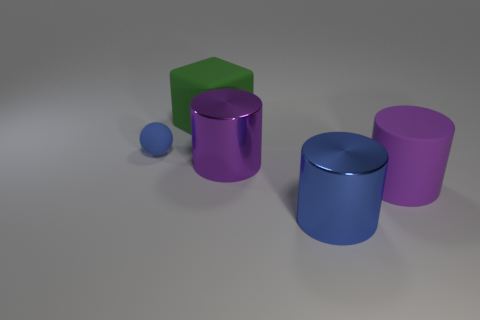There is a blue metallic thing; does it have the same shape as the large purple matte object in front of the small sphere?
Offer a terse response. Yes. There is a matte thing that is right of the tiny matte thing and behind the big rubber cylinder; what is its size?
Make the answer very short. Large. Is there a large blue object that has the same material as the tiny ball?
Provide a succinct answer. No. There is a shiny thing that is the same color as the tiny ball; what is its size?
Ensure brevity in your answer.  Large. There is a blue ball that is to the left of the big matte object that is behind the small blue matte ball; what is it made of?
Provide a succinct answer. Rubber. What number of big metal things are the same color as the large matte cylinder?
Give a very brief answer. 1. The object that is made of the same material as the blue cylinder is what size?
Your answer should be compact. Large. There is a large matte thing in front of the small object; what is its shape?
Your response must be concise. Cylinder. The purple metallic thing that is the same shape as the large purple matte thing is what size?
Keep it short and to the point. Large. What number of small things are in front of the big metallic cylinder behind the purple cylinder right of the blue metal thing?
Your answer should be very brief. 0. 